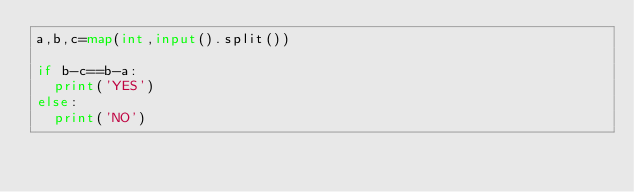Convert code to text. <code><loc_0><loc_0><loc_500><loc_500><_Python_>a,b,c=map(int,input().split())

if b-c==b-a:
  print('YES')
else:
  print('NO')</code> 